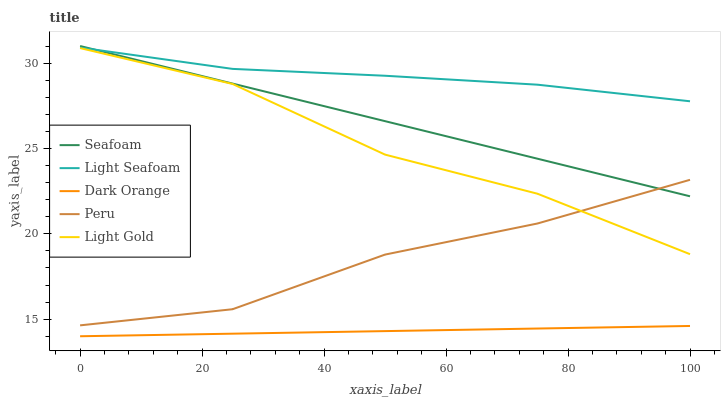Does Dark Orange have the minimum area under the curve?
Answer yes or no. Yes. Does Light Seafoam have the maximum area under the curve?
Answer yes or no. Yes. Does Light Gold have the minimum area under the curve?
Answer yes or no. No. Does Light Gold have the maximum area under the curve?
Answer yes or no. No. Is Seafoam the smoothest?
Answer yes or no. Yes. Is Light Gold the roughest?
Answer yes or no. Yes. Is Light Seafoam the smoothest?
Answer yes or no. No. Is Light Seafoam the roughest?
Answer yes or no. No. Does Dark Orange have the lowest value?
Answer yes or no. Yes. Does Light Gold have the lowest value?
Answer yes or no. No. Does Seafoam have the highest value?
Answer yes or no. Yes. Does Light Seafoam have the highest value?
Answer yes or no. No. Is Light Gold less than Seafoam?
Answer yes or no. Yes. Is Seafoam greater than Light Gold?
Answer yes or no. Yes. Does Light Seafoam intersect Seafoam?
Answer yes or no. Yes. Is Light Seafoam less than Seafoam?
Answer yes or no. No. Is Light Seafoam greater than Seafoam?
Answer yes or no. No. Does Light Gold intersect Seafoam?
Answer yes or no. No. 